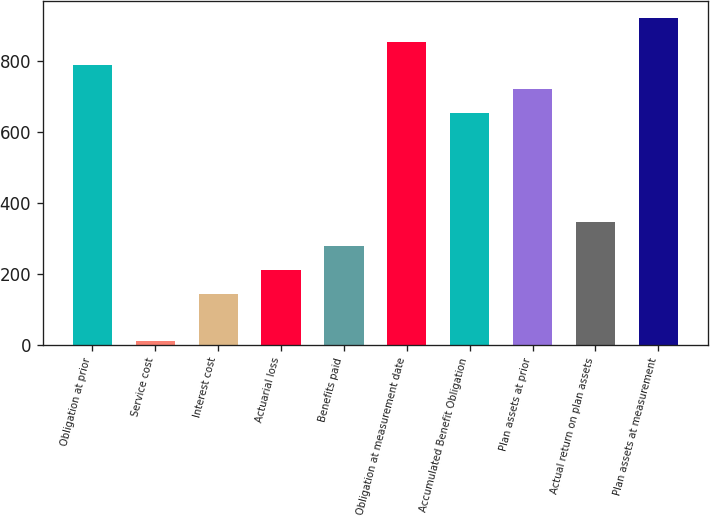Convert chart. <chart><loc_0><loc_0><loc_500><loc_500><bar_chart><fcel>Obligation at prior<fcel>Service cost<fcel>Interest cost<fcel>Actuarial loss<fcel>Benefits paid<fcel>Obligation at measurement date<fcel>Accumulated Benefit Obligation<fcel>Plan assets at prior<fcel>Actual return on plan assets<fcel>Plan assets at measurement<nl><fcel>787<fcel>9<fcel>144<fcel>211.5<fcel>279<fcel>854.5<fcel>652<fcel>719.5<fcel>346.5<fcel>922<nl></chart> 